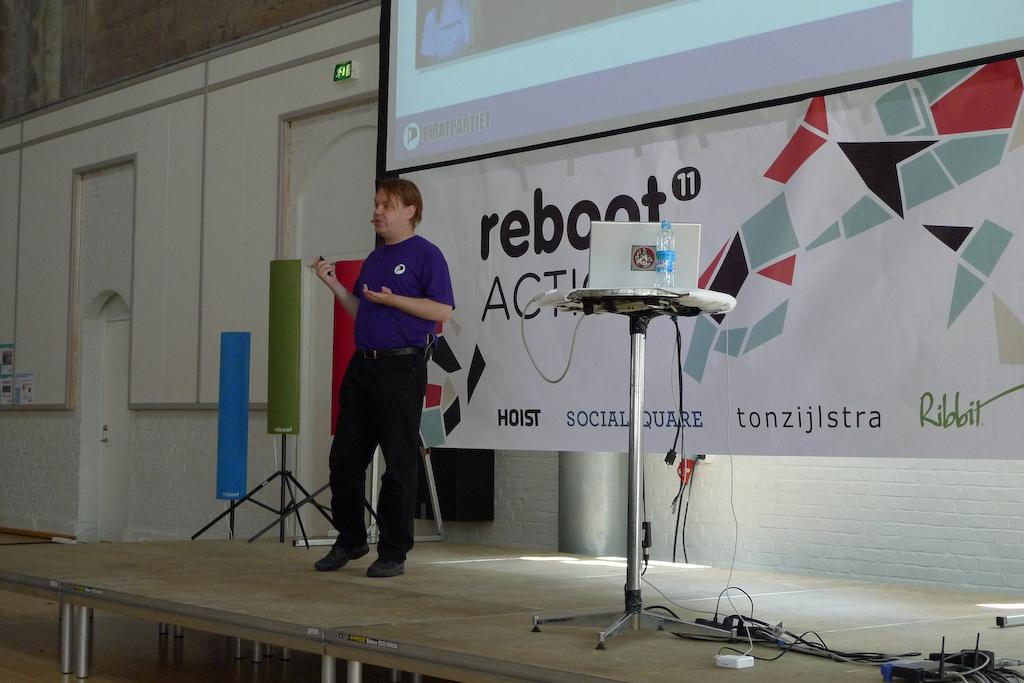What is the man in the image doing? The man is standing on stage. What objects can be seen on the table in the image? There is a laptop and a bottle on the table. What other items are visible in the image? There are wires, a banner, a screen, and speakers in the image. What can be seen in the background of the image? There is a wall visible in the background. How many snails can be seen crawling on the banner in the image? There are no snails visible in the image; the banner is snail-free. 